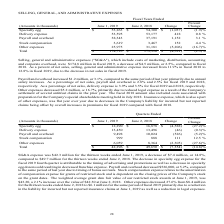Looking at Cal Maine Foods's financial data, please calculate: What is the specialty egg as a percentage of total total selling, general and administrative expenses in 2019? Based on the calculation: 53,263 / 174,795, the result is 30.47 (percentage). This is based on the information: "er expenses 25,975 31,181 (5,206) (16.7)% Total $ 174,795 $ 179,316 $ (4,521) (2.5)% une 2, 2018 Change Percent Change Specialty egg $ 53,263 $ 54,300 $ (1,037) (1.9)% Delivery expense 53,595 53,177 4..." The key data points involved are: 174,795, 53,263. Also, What is the percent change of Delivery Expense from 2018 to 2019? According to the financial document, 0.8%. The relevant text states: "(1,037) (1.9)% Delivery expense 53,595 53,177 418 0.8 % Payroll and overhead 38,343 37,191 1,152 3.1 % Stock compensation 3,619 3,467 152 4.4 % Other exp..." Also, What is the rationale for increase / (decrease) in the selling, general and administrative expense as a percentage of net sales? due to the decrease in net sales in fiscal 2019. The document states: "rom 11.9% in fiscal 2018 to 12.8% in fiscal 2019, due to the decrease in net sales in fiscal 2019. rom 11.9% in fiscal 2018 to 12.8% in fiscal 2019, d..." Also, What caused the increase in payroll and overhead expenses in 2019? due to annual salary increase. The document states: "compared to the same period of last year primarily due to annual salary increases. As a percentage of net sales, payroll and overhead is 2.8% and 2.5%..." Also, can you calculate: what is other expenses constitutes as a percentage of total cost in 2019? Based on the calculation: 25,975 / $174,795, the result is 14.86 (percentage). This is based on the information: "compensation 3,619 3,467 152 4.4 % Other expenses 25,975 31,181 (5,206) (16.7)% Total $ 174,795 $ 179,316 $ (4,521) (2.5)% er expenses 25,975 31,181 (5,206) (16.7)% Total $ 174,795 $ 179,316 $ (4,521)..." The key data points involved are: 174,795, 25,975. Also, can you calculate: What percentage of total cost does stock compensation form a part of? Based on the calculation: 3,619 / $174,795, the result is 2.07 (percentage). This is based on the information: "head 38,343 37,191 1,152 3.1 % Stock compensation 3,619 3,467 152 4.4 % Other expenses 25,975 31,181 (5,206) (16.7)% Total $ 174,795 $ 179,316 $ (4,521) (2 er expenses 25,975 31,181 (5,206) (16.7)% To..." The key data points involved are: 174,795, 3,619. 